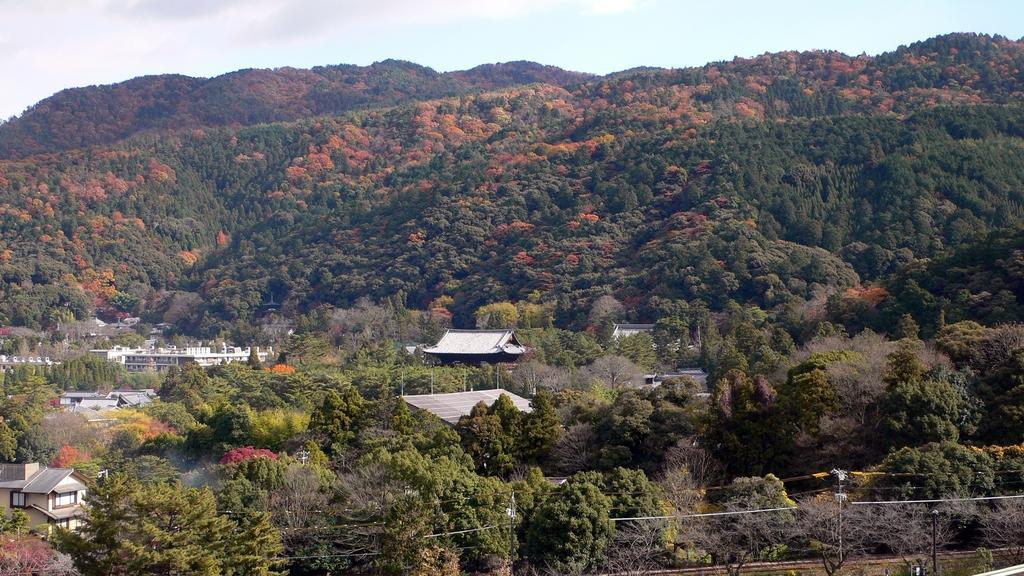Can you describe this image briefly? In this picture there are houses in the center of the image and there are trees around the area of the image, there are poles at the bottom side of the image. 